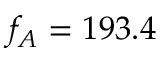<formula> <loc_0><loc_0><loc_500><loc_500>f _ { A } = 1 9 3 . 4</formula> 